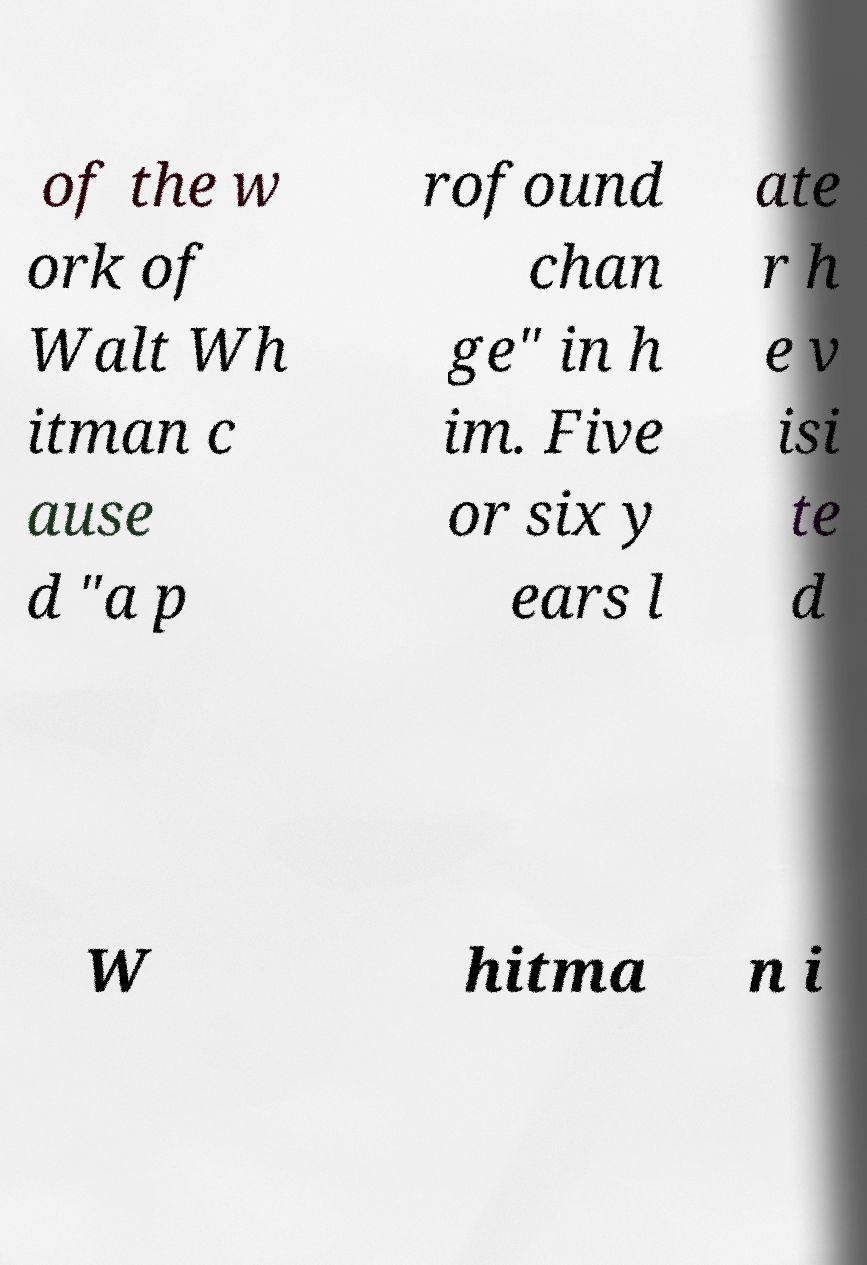Can you accurately transcribe the text from the provided image for me? of the w ork of Walt Wh itman c ause d "a p rofound chan ge" in h im. Five or six y ears l ate r h e v isi te d W hitma n i 